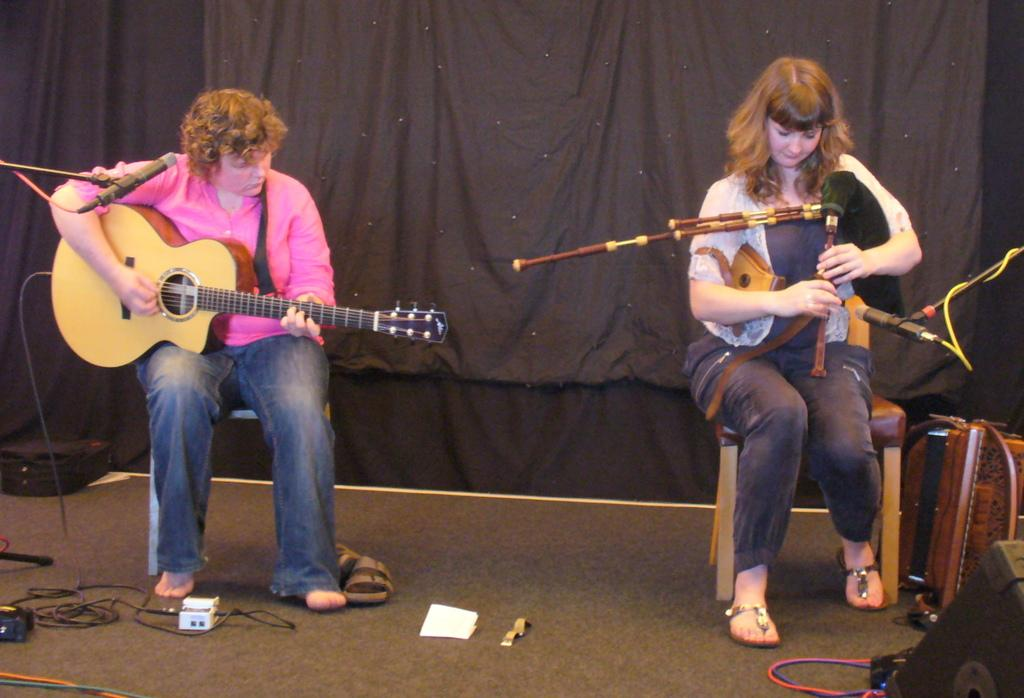How many people are in the image? There are two women in the image. What is one of the women doing in the image? One of the women is playing a guitar. What is the other woman doing in the image? The other woman is looking at the instrument. What are the women sitting on in the image? Both women are sitting in chairs. Can you tell me how many brothers are present in the image? There are no brothers present in the image; it features two women. What type of animal is looking at the guitar in the image? There are no animals present in the image; both women are human. 